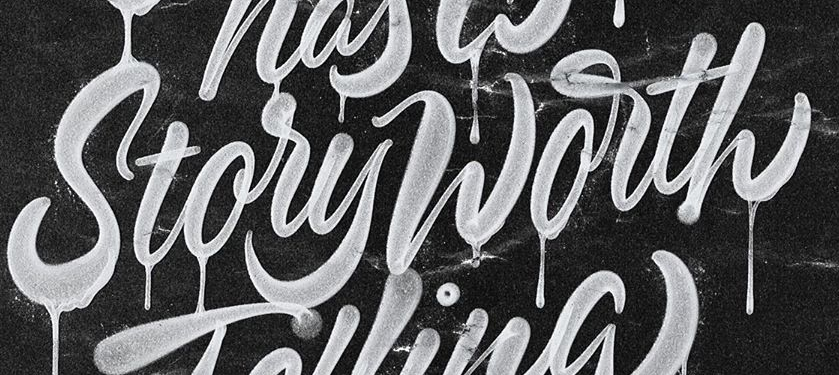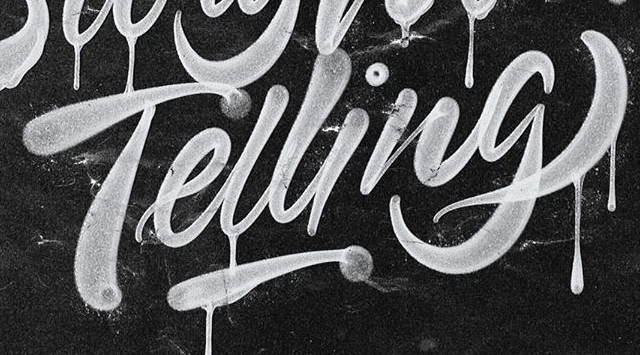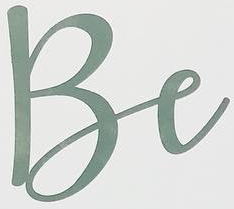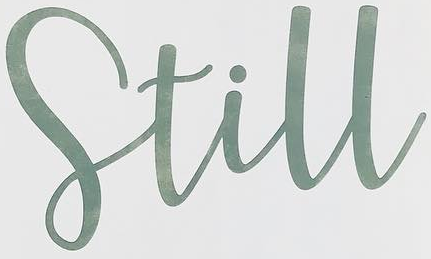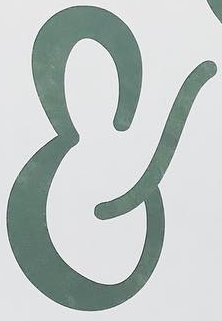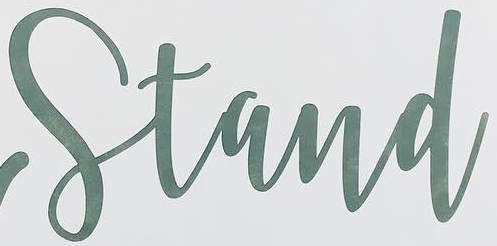What text appears in these images from left to right, separated by a semicolon? StoryWorth; Telling; Be; Still; &; Stand 